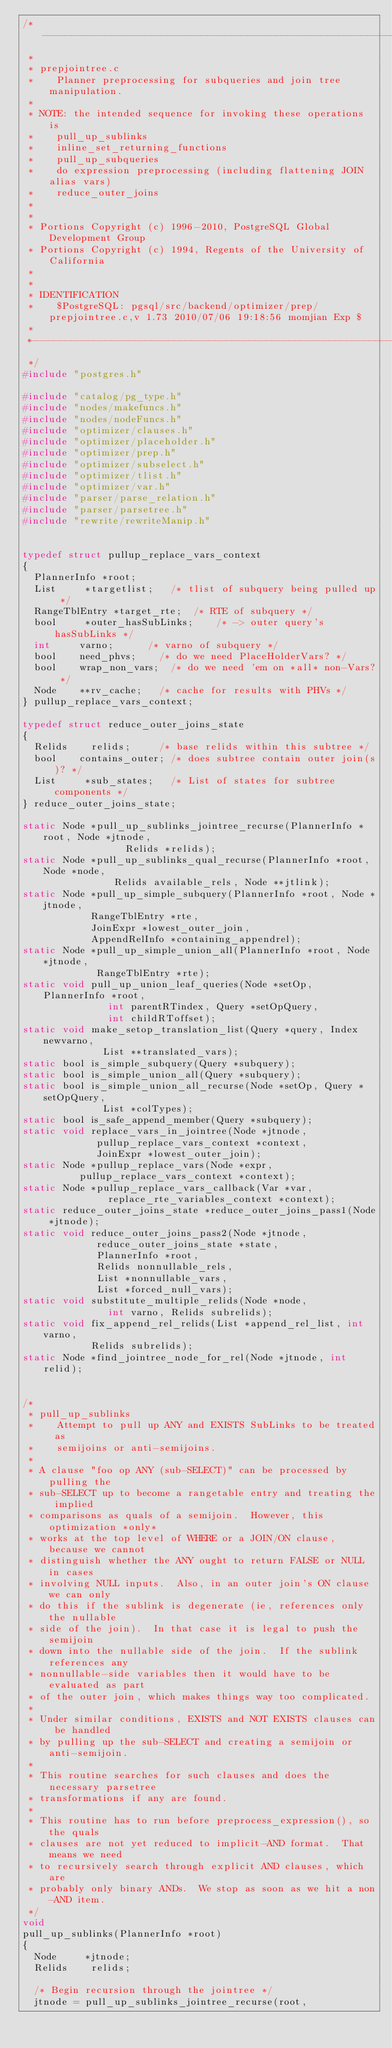Convert code to text. <code><loc_0><loc_0><loc_500><loc_500><_C_>/*-------------------------------------------------------------------------
 *
 * prepjointree.c
 *	  Planner preprocessing for subqueries and join tree manipulation.
 *
 * NOTE: the intended sequence for invoking these operations is
 *		pull_up_sublinks
 *		inline_set_returning_functions
 *		pull_up_subqueries
 *		do expression preprocessing (including flattening JOIN alias vars)
 *		reduce_outer_joins
 *
 *
 * Portions Copyright (c) 1996-2010, PostgreSQL Global Development Group
 * Portions Copyright (c) 1994, Regents of the University of California
 *
 *
 * IDENTIFICATION
 *	  $PostgreSQL: pgsql/src/backend/optimizer/prep/prepjointree.c,v 1.73 2010/07/06 19:18:56 momjian Exp $
 *
 *-------------------------------------------------------------------------
 */
#include "postgres.h"

#include "catalog/pg_type.h"
#include "nodes/makefuncs.h"
#include "nodes/nodeFuncs.h"
#include "optimizer/clauses.h"
#include "optimizer/placeholder.h"
#include "optimizer/prep.h"
#include "optimizer/subselect.h"
#include "optimizer/tlist.h"
#include "optimizer/var.h"
#include "parser/parse_relation.h"
#include "parser/parsetree.h"
#include "rewrite/rewriteManip.h"


typedef struct pullup_replace_vars_context
{
	PlannerInfo *root;
	List	   *targetlist;		/* tlist of subquery being pulled up */
	RangeTblEntry *target_rte;	/* RTE of subquery */
	bool	   *outer_hasSubLinks;		/* -> outer query's hasSubLinks */
	int			varno;			/* varno of subquery */
	bool		need_phvs;		/* do we need PlaceHolderVars? */
	bool		wrap_non_vars;	/* do we need 'em on *all* non-Vars? */
	Node	  **rv_cache;		/* cache for results with PHVs */
} pullup_replace_vars_context;

typedef struct reduce_outer_joins_state
{
	Relids		relids;			/* base relids within this subtree */
	bool		contains_outer; /* does subtree contain outer join(s)? */
	List	   *sub_states;		/* List of states for subtree components */
} reduce_outer_joins_state;

static Node *pull_up_sublinks_jointree_recurse(PlannerInfo *root, Node *jtnode,
								  Relids *relids);
static Node *pull_up_sublinks_qual_recurse(PlannerInfo *root, Node *node,
							  Relids available_rels, Node **jtlink);
static Node *pull_up_simple_subquery(PlannerInfo *root, Node *jtnode,
						RangeTblEntry *rte,
						JoinExpr *lowest_outer_join,
						AppendRelInfo *containing_appendrel);
static Node *pull_up_simple_union_all(PlannerInfo *root, Node *jtnode,
						 RangeTblEntry *rte);
static void pull_up_union_leaf_queries(Node *setOp, PlannerInfo *root,
						   int parentRTindex, Query *setOpQuery,
						   int childRToffset);
static void make_setop_translation_list(Query *query, Index newvarno,
							List **translated_vars);
static bool is_simple_subquery(Query *subquery);
static bool is_simple_union_all(Query *subquery);
static bool is_simple_union_all_recurse(Node *setOp, Query *setOpQuery,
							List *colTypes);
static bool is_safe_append_member(Query *subquery);
static void replace_vars_in_jointree(Node *jtnode,
						 pullup_replace_vars_context *context,
						 JoinExpr *lowest_outer_join);
static Node *pullup_replace_vars(Node *expr,
					pullup_replace_vars_context *context);
static Node *pullup_replace_vars_callback(Var *var,
							 replace_rte_variables_context *context);
static reduce_outer_joins_state *reduce_outer_joins_pass1(Node *jtnode);
static void reduce_outer_joins_pass2(Node *jtnode,
						 reduce_outer_joins_state *state,
						 PlannerInfo *root,
						 Relids nonnullable_rels,
						 List *nonnullable_vars,
						 List *forced_null_vars);
static void substitute_multiple_relids(Node *node,
						   int varno, Relids subrelids);
static void fix_append_rel_relids(List *append_rel_list, int varno,
					  Relids subrelids);
static Node *find_jointree_node_for_rel(Node *jtnode, int relid);


/*
 * pull_up_sublinks
 *		Attempt to pull up ANY and EXISTS SubLinks to be treated as
 *		semijoins or anti-semijoins.
 *
 * A clause "foo op ANY (sub-SELECT)" can be processed by pulling the
 * sub-SELECT up to become a rangetable entry and treating the implied
 * comparisons as quals of a semijoin.	However, this optimization *only*
 * works at the top level of WHERE or a JOIN/ON clause, because we cannot
 * distinguish whether the ANY ought to return FALSE or NULL in cases
 * involving NULL inputs.  Also, in an outer join's ON clause we can only
 * do this if the sublink is degenerate (ie, references only the nullable
 * side of the join).  In that case it is legal to push the semijoin
 * down into the nullable side of the join.  If the sublink references any
 * nonnullable-side variables then it would have to be evaluated as part
 * of the outer join, which makes things way too complicated.
 *
 * Under similar conditions, EXISTS and NOT EXISTS clauses can be handled
 * by pulling up the sub-SELECT and creating a semijoin or anti-semijoin.
 *
 * This routine searches for such clauses and does the necessary parsetree
 * transformations if any are found.
 *
 * This routine has to run before preprocess_expression(), so the quals
 * clauses are not yet reduced to implicit-AND format.	That means we need
 * to recursively search through explicit AND clauses, which are
 * probably only binary ANDs.  We stop as soon as we hit a non-AND item.
 */
void
pull_up_sublinks(PlannerInfo *root)
{
	Node	   *jtnode;
	Relids		relids;

	/* Begin recursion through the jointree */
	jtnode = pull_up_sublinks_jointree_recurse(root,</code> 